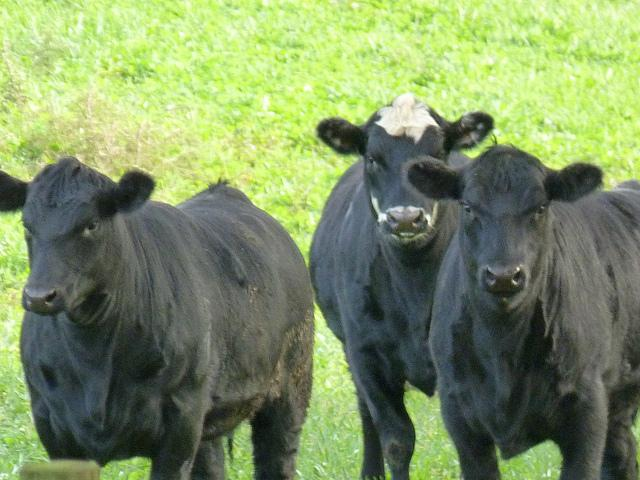How many black cows are standing up in the middle of the pasture?

Choices:
A) four
B) two
C) five
D) three three 